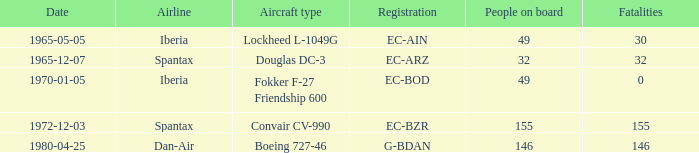How many individuals are aboard the iberia airline's lockheed l-1049g aircraft? 49.0. 